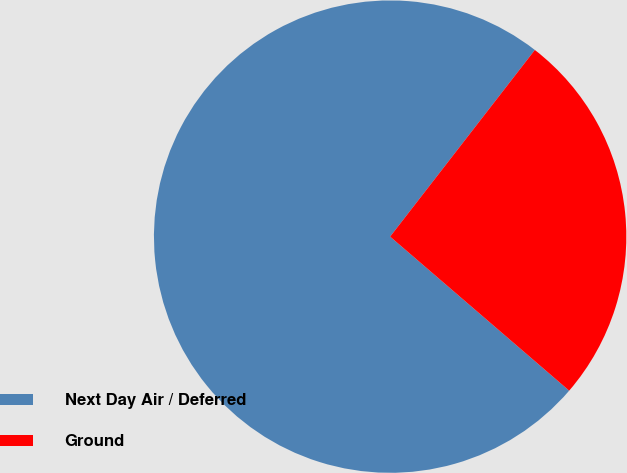Convert chart to OTSL. <chart><loc_0><loc_0><loc_500><loc_500><pie_chart><fcel>Next Day Air / Deferred<fcel>Ground<nl><fcel>74.19%<fcel>25.81%<nl></chart> 